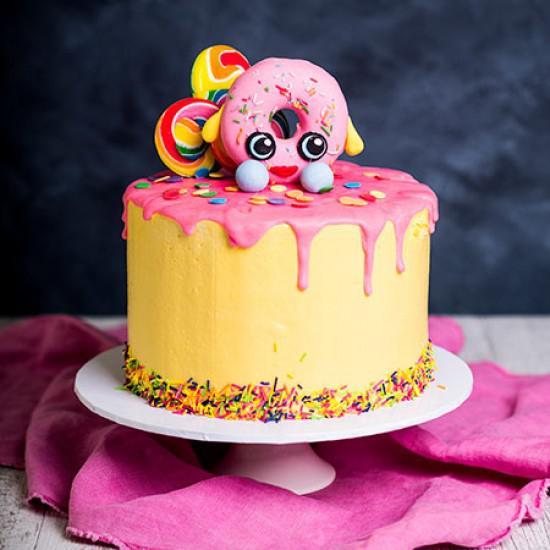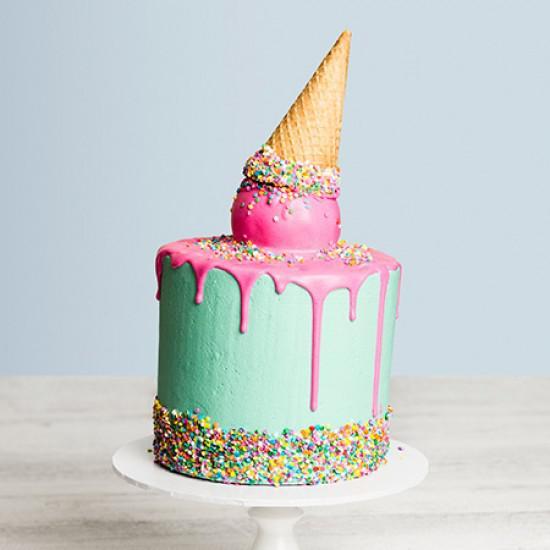The first image is the image on the left, the second image is the image on the right. Considering the images on both sides, is "Each image contains one cake with drip frosting effect and a ring of confetti sprinkles around the bottom, and the cake on the right has an inverted ice cream cone on its top." valid? Answer yes or no. Yes. The first image is the image on the left, the second image is the image on the right. For the images shown, is this caption "In at least one image there is an ice cream cone on top of a frosting drip cake." true? Answer yes or no. Yes. 